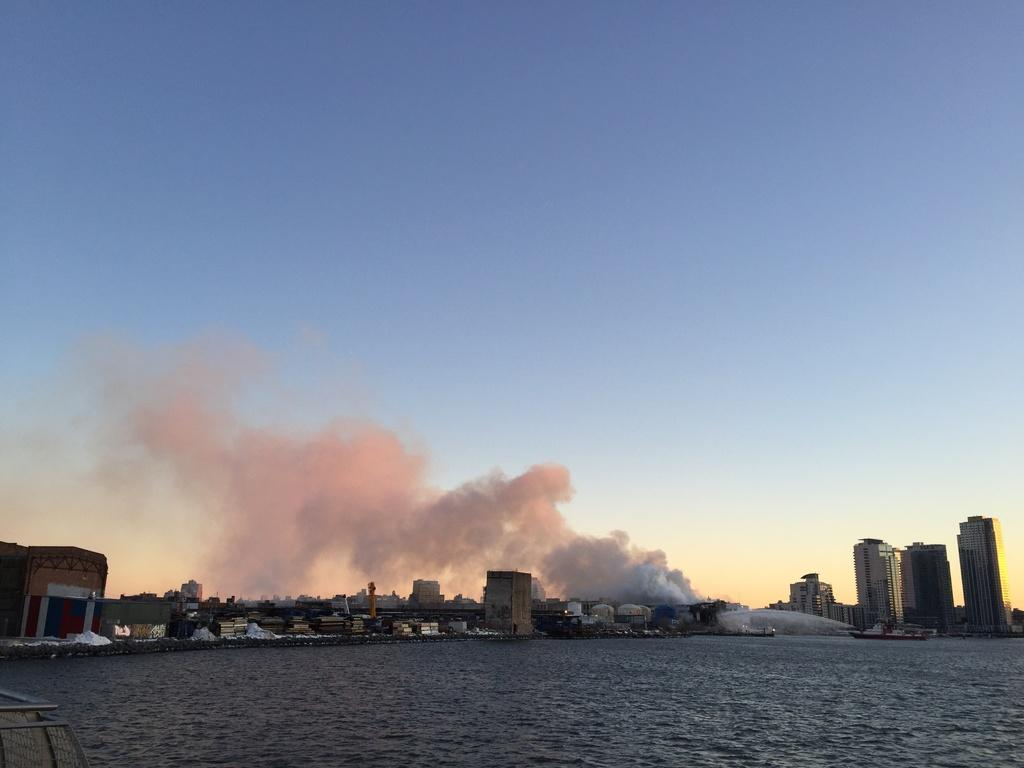What is at the bottom of the image? There is water at the bottom of the image. What can be seen in the middle of the image? There are buildings in the middle of the image. What is present in the sky? There is smoke in the sky. What is located on the right side of the image? There is a boat on the right side of the image. What is visible at the top of the image? The sky is visible at the top of the image. Where are the fairies hiding in the image? There are no fairies present in the image. What type of clocks can be seen in the image? There are no clocks visible in the image. 